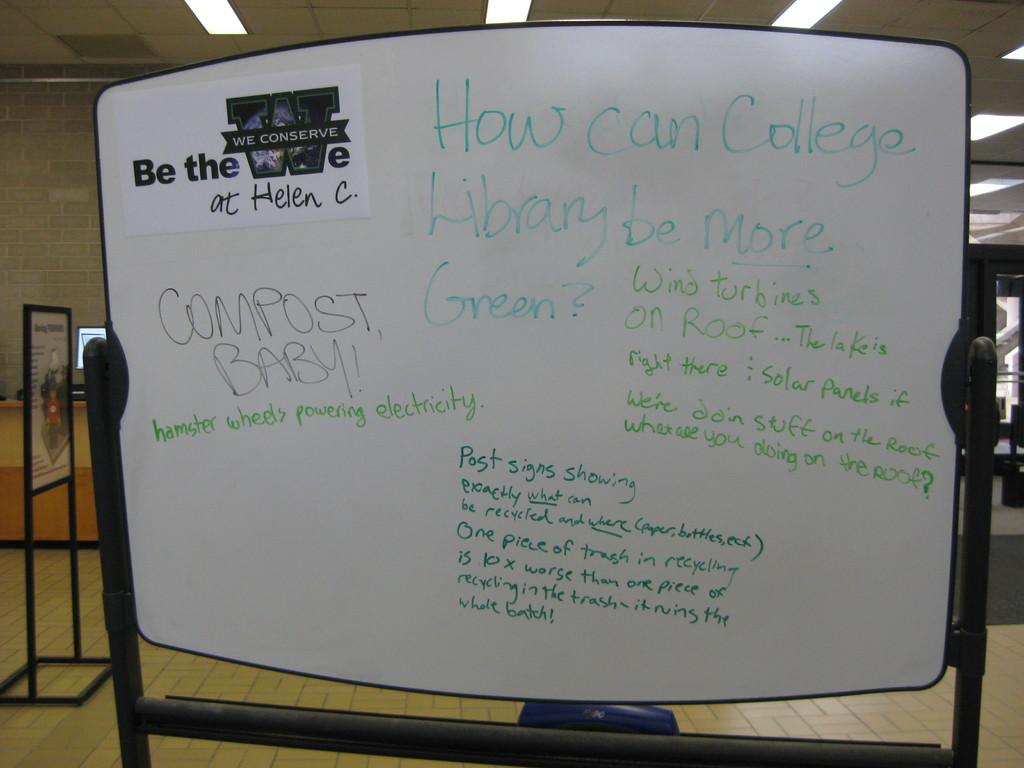<image>
Render a clear and concise summary of the photo. A white board asking the question of how a college library can be more green 